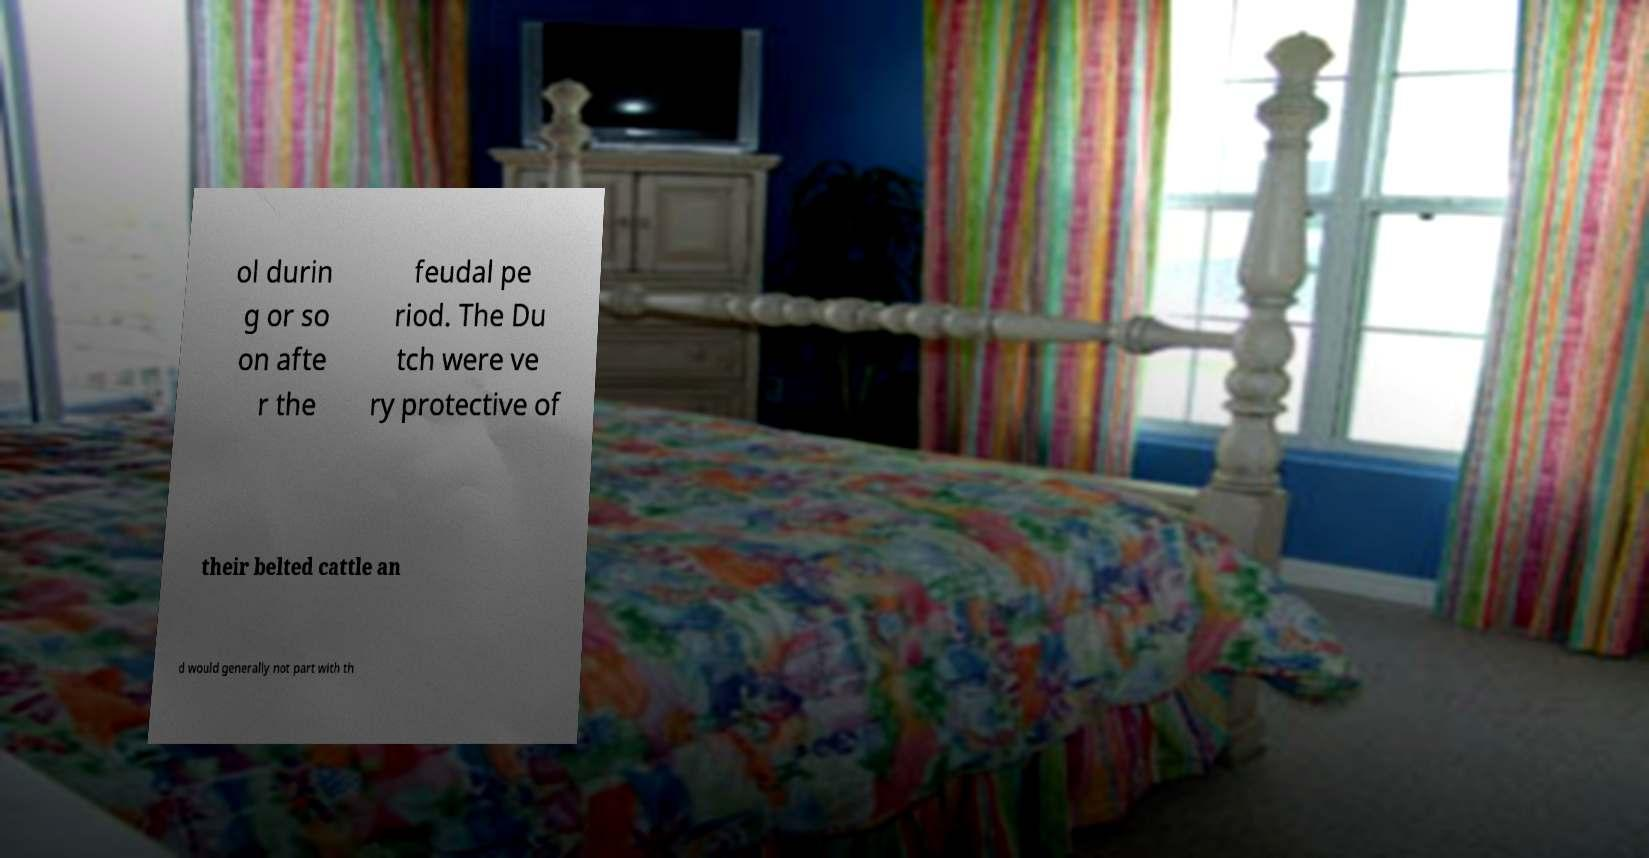Can you read and provide the text displayed in the image?This photo seems to have some interesting text. Can you extract and type it out for me? ol durin g or so on afte r the feudal pe riod. The Du tch were ve ry protective of their belted cattle an d would generally not part with th 